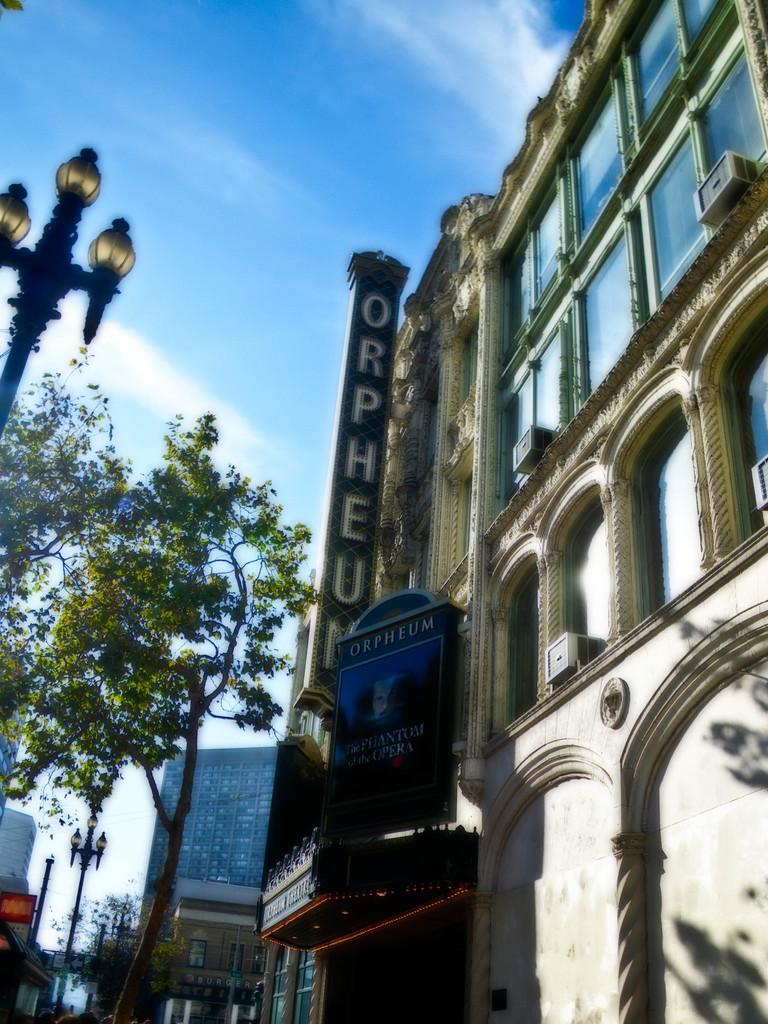What type of structures can be seen in the image? There are many buildings in the image. What is located on the left side of the image? There are trees and street lights on the left side of the image. What is visible at the top of the image? The sky is visible at the top of the image. What can be seen in the sky? Clouds are present in the sky. How many rocks can be seen in the image? There are no rocks visible in the image. 